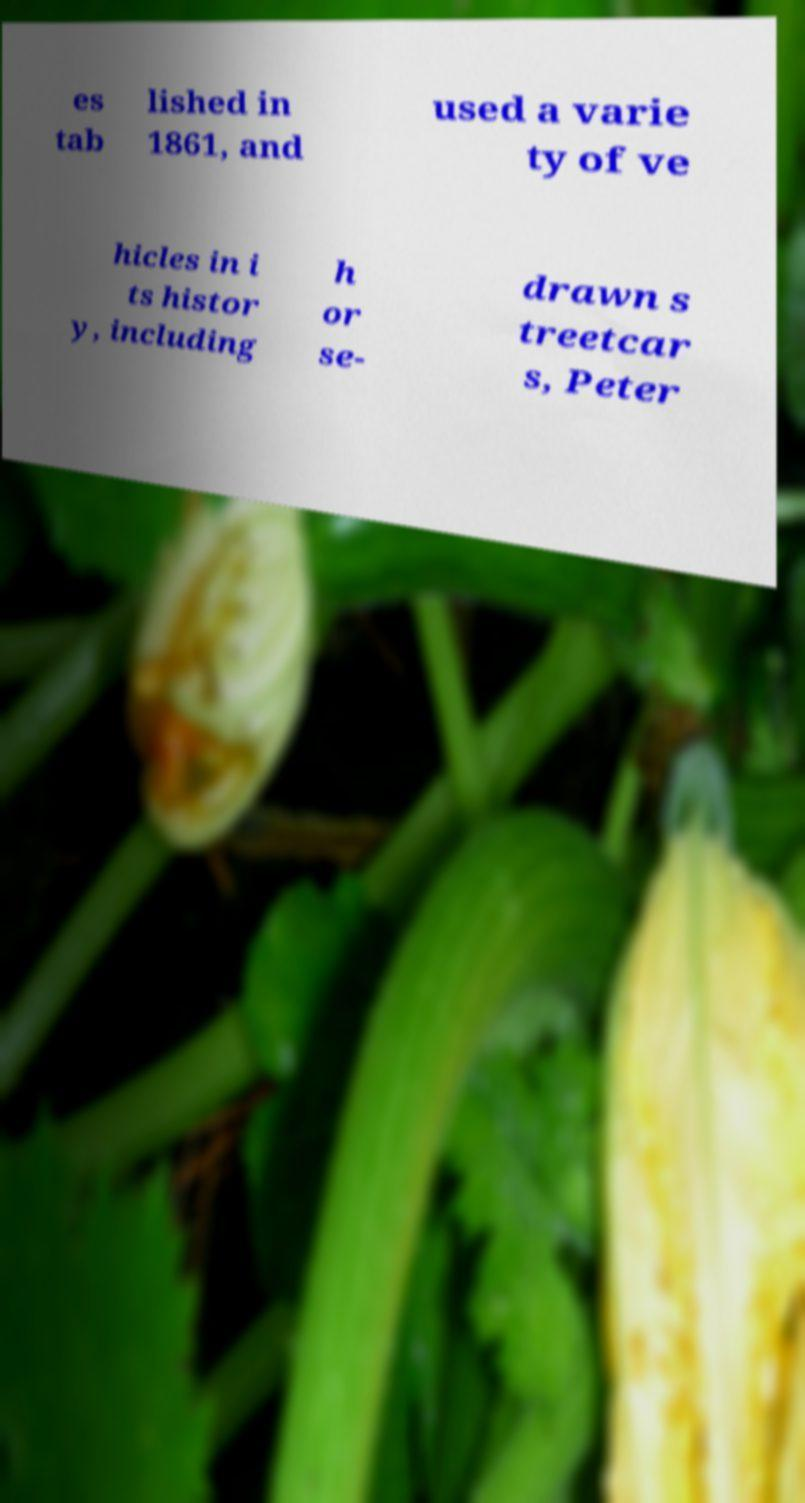Can you read and provide the text displayed in the image?This photo seems to have some interesting text. Can you extract and type it out for me? es tab lished in 1861, and used a varie ty of ve hicles in i ts histor y, including h or se- drawn s treetcar s, Peter 